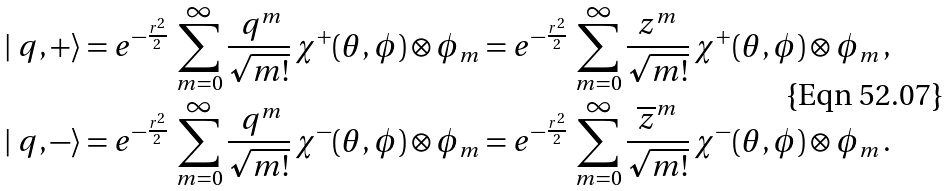Convert formula to latex. <formula><loc_0><loc_0><loc_500><loc_500>| \ q , + \rangle & = e ^ { - \frac { r ^ { 2 } } 2 } \, \sum _ { m = 0 } ^ { \infty } \frac { \ q ^ { m } } { \sqrt { m ! } } \, \chi ^ { + } ( \theta , \phi ) \otimes \phi _ { m } = e ^ { - \frac { r ^ { 2 } } 2 } \, \sum _ { m = 0 } ^ { \infty } \frac { z ^ { m } } { \sqrt { m ! } } \, \chi ^ { + } ( \theta , \phi ) \otimes \phi _ { m } \, , \\ | \ q , - \rangle & = e ^ { - \frac { r ^ { 2 } } 2 } \, \sum _ { m = 0 } ^ { \infty } \frac { \ q ^ { m } } { \sqrt { m ! } } \, \chi ^ { - } ( \theta , \phi ) \otimes \phi _ { m } = e ^ { - \frac { r ^ { 2 } } 2 } \, \sum _ { m = 0 } ^ { \infty } \frac { \overline { z } ^ { m } } { \sqrt { m ! } } \, \chi ^ { - } ( \theta , \phi ) \otimes \phi _ { m } \, .</formula> 